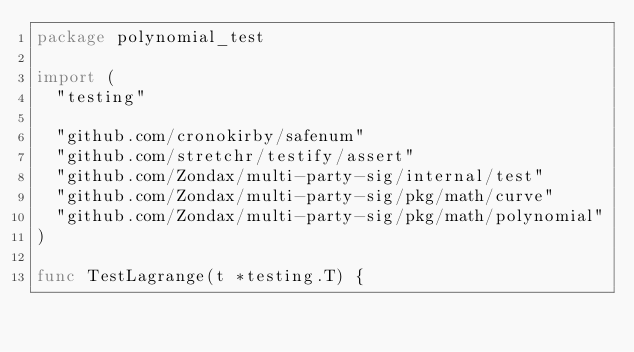Convert code to text. <code><loc_0><loc_0><loc_500><loc_500><_Go_>package polynomial_test

import (
	"testing"

	"github.com/cronokirby/safenum"
	"github.com/stretchr/testify/assert"
	"github.com/Zondax/multi-party-sig/internal/test"
	"github.com/Zondax/multi-party-sig/pkg/math/curve"
	"github.com/Zondax/multi-party-sig/pkg/math/polynomial"
)

func TestLagrange(t *testing.T) {</code> 